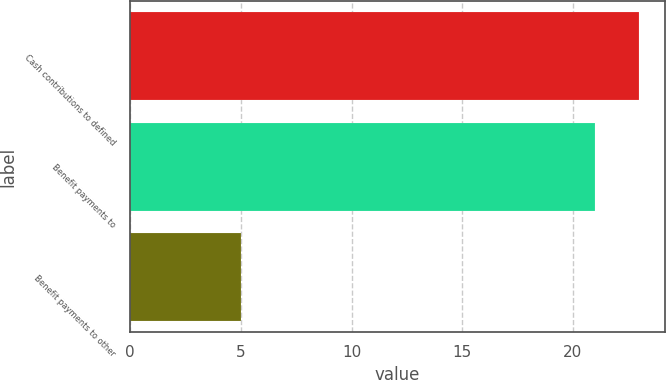Convert chart to OTSL. <chart><loc_0><loc_0><loc_500><loc_500><bar_chart><fcel>Cash contributions to defined<fcel>Benefit payments to<fcel>Benefit payments to other<nl><fcel>23<fcel>21<fcel>5<nl></chart> 